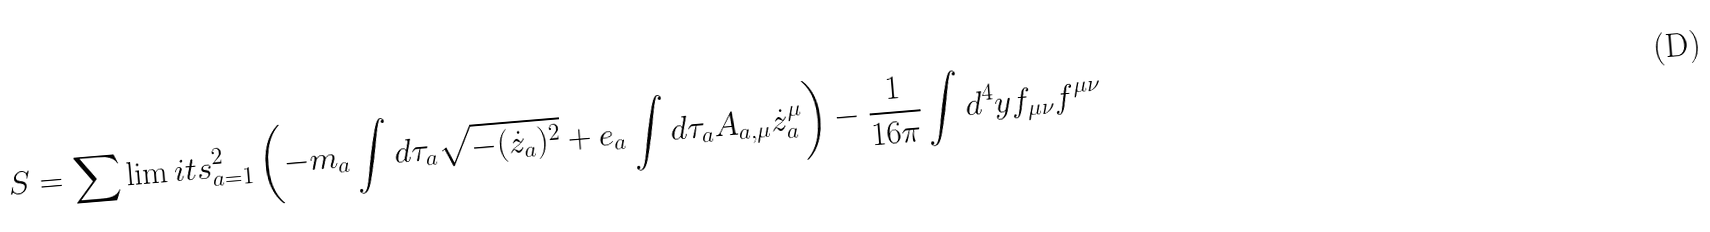<formula> <loc_0><loc_0><loc_500><loc_500>S = \sum \lim i t s _ { a = 1 } ^ { 2 } \left ( - m _ { a } \int d \tau _ { a } \sqrt { - ( { \dot { z } } _ { a } ) ^ { 2 } } + e _ { a } \int d \tau _ { a } A _ { a , \mu } { \dot { z } } _ { a } ^ { \mu } \right ) - \frac { 1 } { 1 6 \pi } \int d ^ { 4 } y f _ { \mu \nu } f ^ { \mu \nu }</formula> 